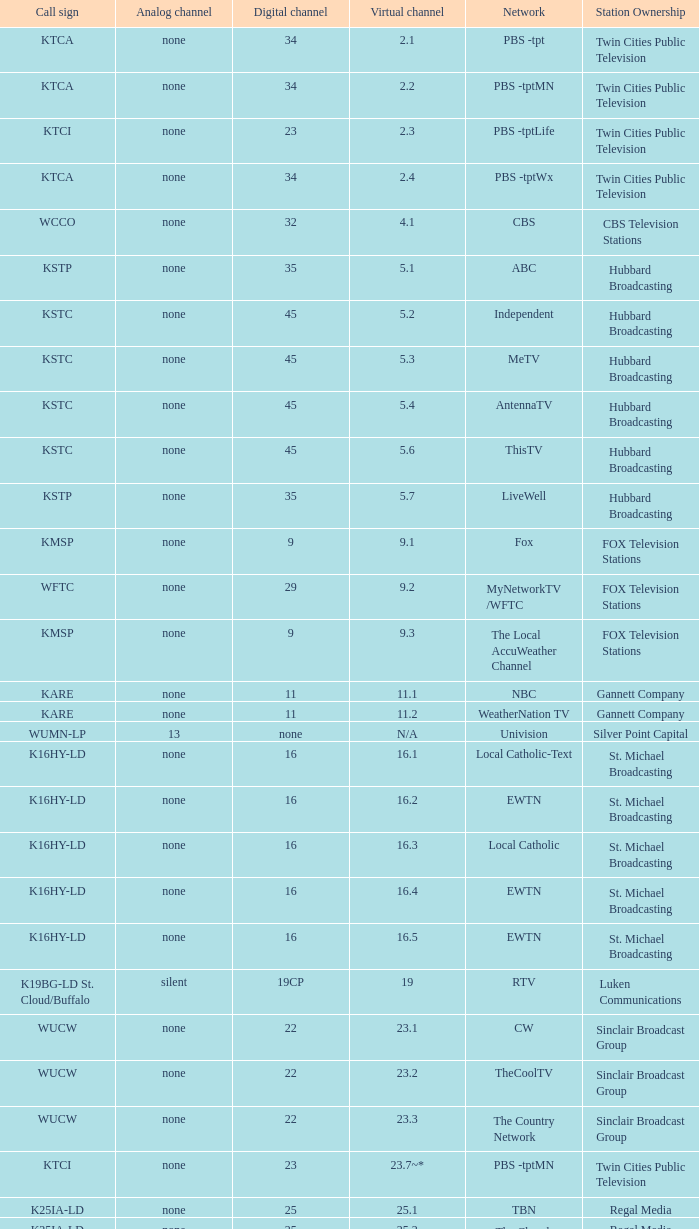Station Ownership of eicb tv, and a Call sign of ktcj-ld is what virtual network? 50.1. 